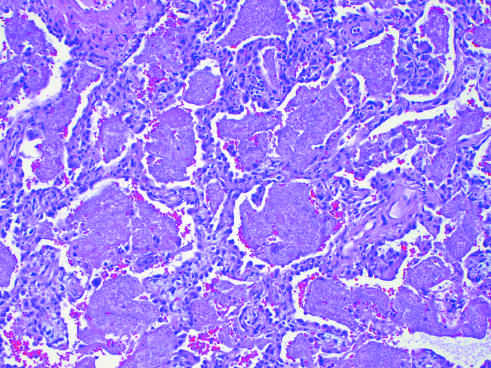what are filled with a characteristic foamy acellular exudate?
Answer the question using a single word or phrase. The alveoli 